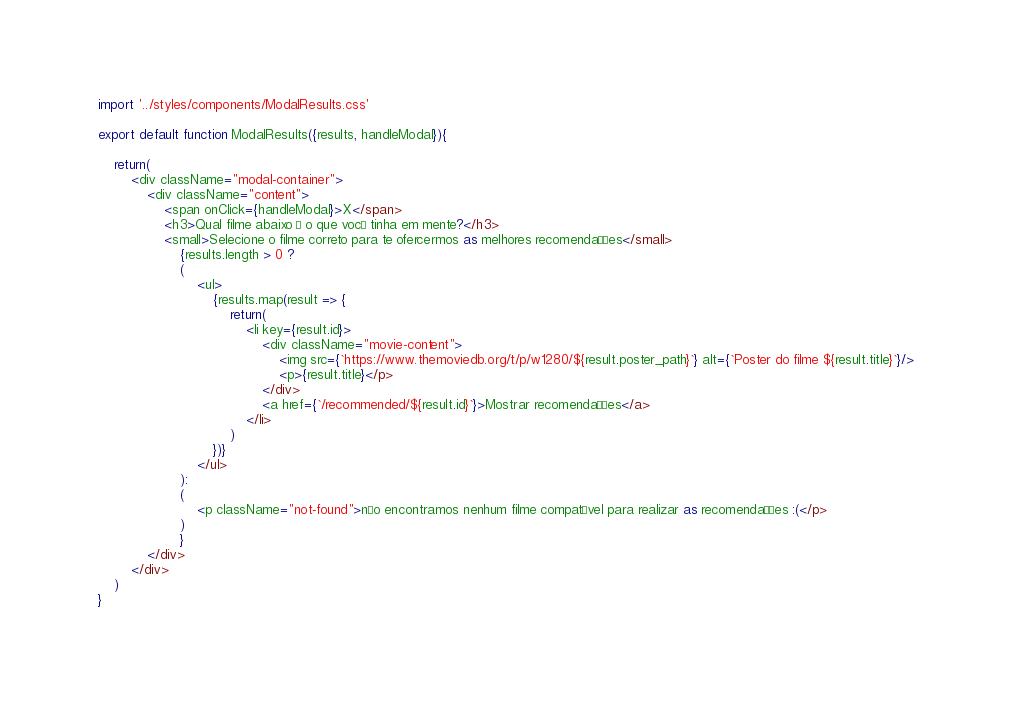Convert code to text. <code><loc_0><loc_0><loc_500><loc_500><_JavaScript_>import '../styles/components/ModalResults.css'

export default function ModalResults({results, handleModal}){

    return(
        <div className="modal-container">
            <div className="content">
                <span onClick={handleModal}>X</span>
                <h3>Qual filme abaixo é o que você tinha em mente?</h3>
                <small>Selecione o filme correto para te ofercermos as melhores recomendações</small>
                    {results.length > 0 ? 
                    (
                        <ul>
                            {results.map(result => {
                                return(
                                    <li key={result.id}>
                                        <div className="movie-content">
                                            <img src={`https://www.themoviedb.org/t/p/w1280/${result.poster_path}`} alt={`Poster do filme ${result.title}`}/>
                                            <p>{result.title}</p>
                                        </div>
                                        <a href={`/recommended/${result.id}`}>Mostrar recomendações</a>
                                    </li>
                                )
                            })}
                        </ul>
                    ): 
                    (
                        <p className="not-found">não encontramos nenhum filme compatível para realizar as recomendações :(</p>
                    )
                    }
            </div>
        </div>
    )
}</code> 